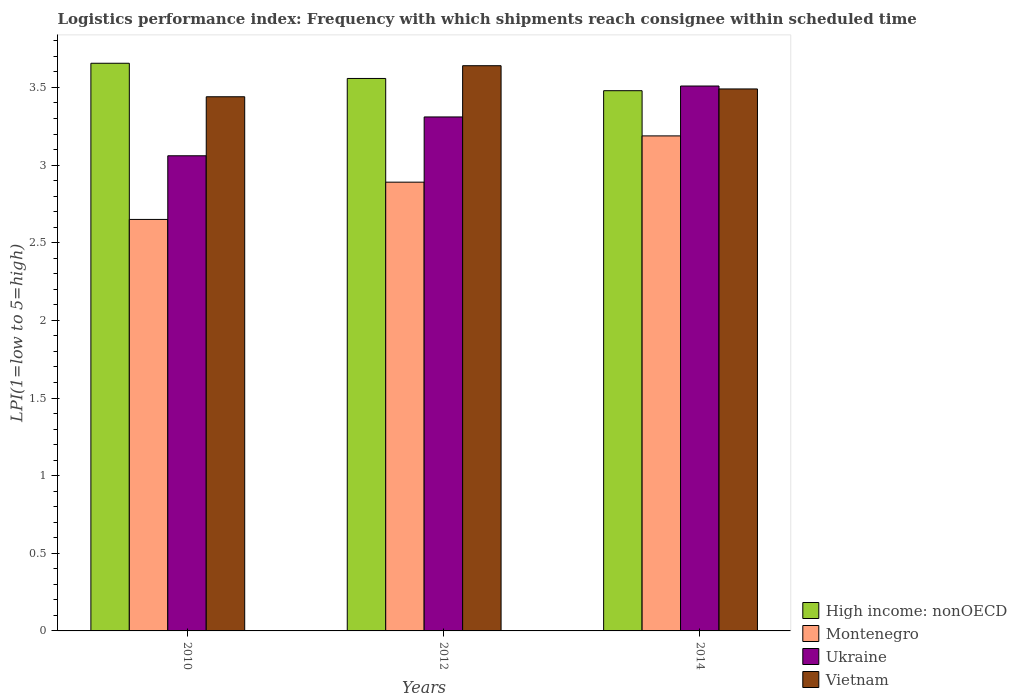How many different coloured bars are there?
Your response must be concise. 4. What is the logistics performance index in High income: nonOECD in 2012?
Your answer should be very brief. 3.56. Across all years, what is the maximum logistics performance index in Montenegro?
Keep it short and to the point. 3.19. Across all years, what is the minimum logistics performance index in Vietnam?
Your answer should be compact. 3.44. In which year was the logistics performance index in Montenegro maximum?
Provide a short and direct response. 2014. In which year was the logistics performance index in Montenegro minimum?
Your answer should be very brief. 2010. What is the total logistics performance index in Montenegro in the graph?
Provide a succinct answer. 8.73. What is the difference between the logistics performance index in High income: nonOECD in 2010 and that in 2014?
Make the answer very short. 0.18. What is the difference between the logistics performance index in Ukraine in 2010 and the logistics performance index in High income: nonOECD in 2012?
Your answer should be compact. -0.5. What is the average logistics performance index in Vietnam per year?
Provide a succinct answer. 3.52. In the year 2014, what is the difference between the logistics performance index in Vietnam and logistics performance index in High income: nonOECD?
Give a very brief answer. 0.01. In how many years, is the logistics performance index in Vietnam greater than 3.5?
Offer a very short reply. 1. What is the ratio of the logistics performance index in Ukraine in 2012 to that in 2014?
Give a very brief answer. 0.94. Is the logistics performance index in Montenegro in 2010 less than that in 2014?
Give a very brief answer. Yes. What is the difference between the highest and the second highest logistics performance index in Montenegro?
Make the answer very short. 0.3. What is the difference between the highest and the lowest logistics performance index in Vietnam?
Your answer should be compact. 0.2. What does the 3rd bar from the left in 2014 represents?
Offer a very short reply. Ukraine. What does the 1st bar from the right in 2012 represents?
Provide a succinct answer. Vietnam. Are all the bars in the graph horizontal?
Your answer should be compact. No. How many years are there in the graph?
Your answer should be very brief. 3. What is the difference between two consecutive major ticks on the Y-axis?
Offer a very short reply. 0.5. Does the graph contain grids?
Provide a short and direct response. No. Where does the legend appear in the graph?
Your response must be concise. Bottom right. How are the legend labels stacked?
Your response must be concise. Vertical. What is the title of the graph?
Your response must be concise. Logistics performance index: Frequency with which shipments reach consignee within scheduled time. Does "Uruguay" appear as one of the legend labels in the graph?
Provide a succinct answer. No. What is the label or title of the Y-axis?
Your answer should be compact. LPI(1=low to 5=high). What is the LPI(1=low to 5=high) in High income: nonOECD in 2010?
Your answer should be compact. 3.66. What is the LPI(1=low to 5=high) of Montenegro in 2010?
Give a very brief answer. 2.65. What is the LPI(1=low to 5=high) in Ukraine in 2010?
Your answer should be compact. 3.06. What is the LPI(1=low to 5=high) in Vietnam in 2010?
Offer a very short reply. 3.44. What is the LPI(1=low to 5=high) in High income: nonOECD in 2012?
Make the answer very short. 3.56. What is the LPI(1=low to 5=high) of Montenegro in 2012?
Your answer should be compact. 2.89. What is the LPI(1=low to 5=high) of Ukraine in 2012?
Keep it short and to the point. 3.31. What is the LPI(1=low to 5=high) in Vietnam in 2012?
Offer a terse response. 3.64. What is the LPI(1=low to 5=high) in High income: nonOECD in 2014?
Your answer should be very brief. 3.48. What is the LPI(1=low to 5=high) in Montenegro in 2014?
Ensure brevity in your answer.  3.19. What is the LPI(1=low to 5=high) of Ukraine in 2014?
Your response must be concise. 3.51. What is the LPI(1=low to 5=high) of Vietnam in 2014?
Your answer should be compact. 3.49. Across all years, what is the maximum LPI(1=low to 5=high) in High income: nonOECD?
Provide a short and direct response. 3.66. Across all years, what is the maximum LPI(1=low to 5=high) in Montenegro?
Your answer should be very brief. 3.19. Across all years, what is the maximum LPI(1=low to 5=high) in Ukraine?
Keep it short and to the point. 3.51. Across all years, what is the maximum LPI(1=low to 5=high) in Vietnam?
Your response must be concise. 3.64. Across all years, what is the minimum LPI(1=low to 5=high) in High income: nonOECD?
Make the answer very short. 3.48. Across all years, what is the minimum LPI(1=low to 5=high) in Montenegro?
Offer a very short reply. 2.65. Across all years, what is the minimum LPI(1=low to 5=high) in Ukraine?
Give a very brief answer. 3.06. Across all years, what is the minimum LPI(1=low to 5=high) of Vietnam?
Your answer should be very brief. 3.44. What is the total LPI(1=low to 5=high) of High income: nonOECD in the graph?
Offer a very short reply. 10.69. What is the total LPI(1=low to 5=high) in Montenegro in the graph?
Make the answer very short. 8.73. What is the total LPI(1=low to 5=high) in Ukraine in the graph?
Your response must be concise. 9.88. What is the total LPI(1=low to 5=high) of Vietnam in the graph?
Offer a very short reply. 10.57. What is the difference between the LPI(1=low to 5=high) of High income: nonOECD in 2010 and that in 2012?
Give a very brief answer. 0.1. What is the difference between the LPI(1=low to 5=high) in Montenegro in 2010 and that in 2012?
Offer a terse response. -0.24. What is the difference between the LPI(1=low to 5=high) of Ukraine in 2010 and that in 2012?
Provide a succinct answer. -0.25. What is the difference between the LPI(1=low to 5=high) of Vietnam in 2010 and that in 2012?
Give a very brief answer. -0.2. What is the difference between the LPI(1=low to 5=high) in High income: nonOECD in 2010 and that in 2014?
Offer a terse response. 0.18. What is the difference between the LPI(1=low to 5=high) of Montenegro in 2010 and that in 2014?
Your response must be concise. -0.54. What is the difference between the LPI(1=low to 5=high) in Ukraine in 2010 and that in 2014?
Offer a terse response. -0.45. What is the difference between the LPI(1=low to 5=high) in Vietnam in 2010 and that in 2014?
Keep it short and to the point. -0.05. What is the difference between the LPI(1=low to 5=high) in High income: nonOECD in 2012 and that in 2014?
Keep it short and to the point. 0.08. What is the difference between the LPI(1=low to 5=high) in Montenegro in 2012 and that in 2014?
Provide a succinct answer. -0.3. What is the difference between the LPI(1=low to 5=high) of Ukraine in 2012 and that in 2014?
Offer a terse response. -0.2. What is the difference between the LPI(1=low to 5=high) in Vietnam in 2012 and that in 2014?
Offer a terse response. 0.15. What is the difference between the LPI(1=low to 5=high) in High income: nonOECD in 2010 and the LPI(1=low to 5=high) in Montenegro in 2012?
Your answer should be very brief. 0.77. What is the difference between the LPI(1=low to 5=high) in High income: nonOECD in 2010 and the LPI(1=low to 5=high) in Ukraine in 2012?
Provide a short and direct response. 0.35. What is the difference between the LPI(1=low to 5=high) of High income: nonOECD in 2010 and the LPI(1=low to 5=high) of Vietnam in 2012?
Your answer should be compact. 0.02. What is the difference between the LPI(1=low to 5=high) in Montenegro in 2010 and the LPI(1=low to 5=high) in Ukraine in 2012?
Your answer should be very brief. -0.66. What is the difference between the LPI(1=low to 5=high) of Montenegro in 2010 and the LPI(1=low to 5=high) of Vietnam in 2012?
Offer a very short reply. -0.99. What is the difference between the LPI(1=low to 5=high) in Ukraine in 2010 and the LPI(1=low to 5=high) in Vietnam in 2012?
Provide a short and direct response. -0.58. What is the difference between the LPI(1=low to 5=high) of High income: nonOECD in 2010 and the LPI(1=low to 5=high) of Montenegro in 2014?
Provide a succinct answer. 0.47. What is the difference between the LPI(1=low to 5=high) of High income: nonOECD in 2010 and the LPI(1=low to 5=high) of Ukraine in 2014?
Offer a very short reply. 0.15. What is the difference between the LPI(1=low to 5=high) of High income: nonOECD in 2010 and the LPI(1=low to 5=high) of Vietnam in 2014?
Offer a terse response. 0.17. What is the difference between the LPI(1=low to 5=high) of Montenegro in 2010 and the LPI(1=low to 5=high) of Ukraine in 2014?
Your answer should be very brief. -0.86. What is the difference between the LPI(1=low to 5=high) of Montenegro in 2010 and the LPI(1=low to 5=high) of Vietnam in 2014?
Offer a terse response. -0.84. What is the difference between the LPI(1=low to 5=high) of Ukraine in 2010 and the LPI(1=low to 5=high) of Vietnam in 2014?
Offer a very short reply. -0.43. What is the difference between the LPI(1=low to 5=high) in High income: nonOECD in 2012 and the LPI(1=low to 5=high) in Montenegro in 2014?
Provide a short and direct response. 0.37. What is the difference between the LPI(1=low to 5=high) in High income: nonOECD in 2012 and the LPI(1=low to 5=high) in Ukraine in 2014?
Make the answer very short. 0.05. What is the difference between the LPI(1=low to 5=high) in High income: nonOECD in 2012 and the LPI(1=low to 5=high) in Vietnam in 2014?
Make the answer very short. 0.07. What is the difference between the LPI(1=low to 5=high) of Montenegro in 2012 and the LPI(1=low to 5=high) of Ukraine in 2014?
Your response must be concise. -0.62. What is the difference between the LPI(1=low to 5=high) in Montenegro in 2012 and the LPI(1=low to 5=high) in Vietnam in 2014?
Your answer should be compact. -0.6. What is the difference between the LPI(1=low to 5=high) in Ukraine in 2012 and the LPI(1=low to 5=high) in Vietnam in 2014?
Provide a succinct answer. -0.18. What is the average LPI(1=low to 5=high) of High income: nonOECD per year?
Your response must be concise. 3.56. What is the average LPI(1=low to 5=high) of Montenegro per year?
Your answer should be very brief. 2.91. What is the average LPI(1=low to 5=high) of Ukraine per year?
Give a very brief answer. 3.29. What is the average LPI(1=low to 5=high) in Vietnam per year?
Offer a terse response. 3.52. In the year 2010, what is the difference between the LPI(1=low to 5=high) of High income: nonOECD and LPI(1=low to 5=high) of Montenegro?
Make the answer very short. 1.01. In the year 2010, what is the difference between the LPI(1=low to 5=high) in High income: nonOECD and LPI(1=low to 5=high) in Ukraine?
Provide a succinct answer. 0.6. In the year 2010, what is the difference between the LPI(1=low to 5=high) in High income: nonOECD and LPI(1=low to 5=high) in Vietnam?
Your response must be concise. 0.22. In the year 2010, what is the difference between the LPI(1=low to 5=high) of Montenegro and LPI(1=low to 5=high) of Ukraine?
Give a very brief answer. -0.41. In the year 2010, what is the difference between the LPI(1=low to 5=high) of Montenegro and LPI(1=low to 5=high) of Vietnam?
Provide a succinct answer. -0.79. In the year 2010, what is the difference between the LPI(1=low to 5=high) in Ukraine and LPI(1=low to 5=high) in Vietnam?
Offer a terse response. -0.38. In the year 2012, what is the difference between the LPI(1=low to 5=high) of High income: nonOECD and LPI(1=low to 5=high) of Montenegro?
Offer a very short reply. 0.67. In the year 2012, what is the difference between the LPI(1=low to 5=high) of High income: nonOECD and LPI(1=low to 5=high) of Ukraine?
Provide a short and direct response. 0.25. In the year 2012, what is the difference between the LPI(1=low to 5=high) in High income: nonOECD and LPI(1=low to 5=high) in Vietnam?
Give a very brief answer. -0.08. In the year 2012, what is the difference between the LPI(1=low to 5=high) of Montenegro and LPI(1=low to 5=high) of Ukraine?
Make the answer very short. -0.42. In the year 2012, what is the difference between the LPI(1=low to 5=high) in Montenegro and LPI(1=low to 5=high) in Vietnam?
Your answer should be compact. -0.75. In the year 2012, what is the difference between the LPI(1=low to 5=high) of Ukraine and LPI(1=low to 5=high) of Vietnam?
Keep it short and to the point. -0.33. In the year 2014, what is the difference between the LPI(1=low to 5=high) of High income: nonOECD and LPI(1=low to 5=high) of Montenegro?
Provide a succinct answer. 0.29. In the year 2014, what is the difference between the LPI(1=low to 5=high) in High income: nonOECD and LPI(1=low to 5=high) in Ukraine?
Offer a terse response. -0.03. In the year 2014, what is the difference between the LPI(1=low to 5=high) of High income: nonOECD and LPI(1=low to 5=high) of Vietnam?
Give a very brief answer. -0.01. In the year 2014, what is the difference between the LPI(1=low to 5=high) of Montenegro and LPI(1=low to 5=high) of Ukraine?
Provide a succinct answer. -0.32. In the year 2014, what is the difference between the LPI(1=low to 5=high) in Montenegro and LPI(1=low to 5=high) in Vietnam?
Provide a succinct answer. -0.3. In the year 2014, what is the difference between the LPI(1=low to 5=high) in Ukraine and LPI(1=low to 5=high) in Vietnam?
Keep it short and to the point. 0.02. What is the ratio of the LPI(1=low to 5=high) of High income: nonOECD in 2010 to that in 2012?
Your response must be concise. 1.03. What is the ratio of the LPI(1=low to 5=high) of Montenegro in 2010 to that in 2012?
Offer a terse response. 0.92. What is the ratio of the LPI(1=low to 5=high) in Ukraine in 2010 to that in 2012?
Provide a short and direct response. 0.92. What is the ratio of the LPI(1=low to 5=high) of Vietnam in 2010 to that in 2012?
Offer a very short reply. 0.95. What is the ratio of the LPI(1=low to 5=high) in High income: nonOECD in 2010 to that in 2014?
Provide a succinct answer. 1.05. What is the ratio of the LPI(1=low to 5=high) of Montenegro in 2010 to that in 2014?
Your answer should be compact. 0.83. What is the ratio of the LPI(1=low to 5=high) of Ukraine in 2010 to that in 2014?
Make the answer very short. 0.87. What is the ratio of the LPI(1=low to 5=high) in Vietnam in 2010 to that in 2014?
Your answer should be very brief. 0.99. What is the ratio of the LPI(1=low to 5=high) in High income: nonOECD in 2012 to that in 2014?
Offer a terse response. 1.02. What is the ratio of the LPI(1=low to 5=high) in Montenegro in 2012 to that in 2014?
Offer a very short reply. 0.91. What is the ratio of the LPI(1=low to 5=high) of Ukraine in 2012 to that in 2014?
Make the answer very short. 0.94. What is the ratio of the LPI(1=low to 5=high) of Vietnam in 2012 to that in 2014?
Provide a short and direct response. 1.04. What is the difference between the highest and the second highest LPI(1=low to 5=high) of High income: nonOECD?
Provide a short and direct response. 0.1. What is the difference between the highest and the second highest LPI(1=low to 5=high) of Montenegro?
Ensure brevity in your answer.  0.3. What is the difference between the highest and the second highest LPI(1=low to 5=high) in Ukraine?
Keep it short and to the point. 0.2. What is the difference between the highest and the second highest LPI(1=low to 5=high) of Vietnam?
Provide a short and direct response. 0.15. What is the difference between the highest and the lowest LPI(1=low to 5=high) in High income: nonOECD?
Provide a short and direct response. 0.18. What is the difference between the highest and the lowest LPI(1=low to 5=high) of Montenegro?
Your answer should be compact. 0.54. What is the difference between the highest and the lowest LPI(1=low to 5=high) of Ukraine?
Make the answer very short. 0.45. What is the difference between the highest and the lowest LPI(1=low to 5=high) of Vietnam?
Your answer should be compact. 0.2. 